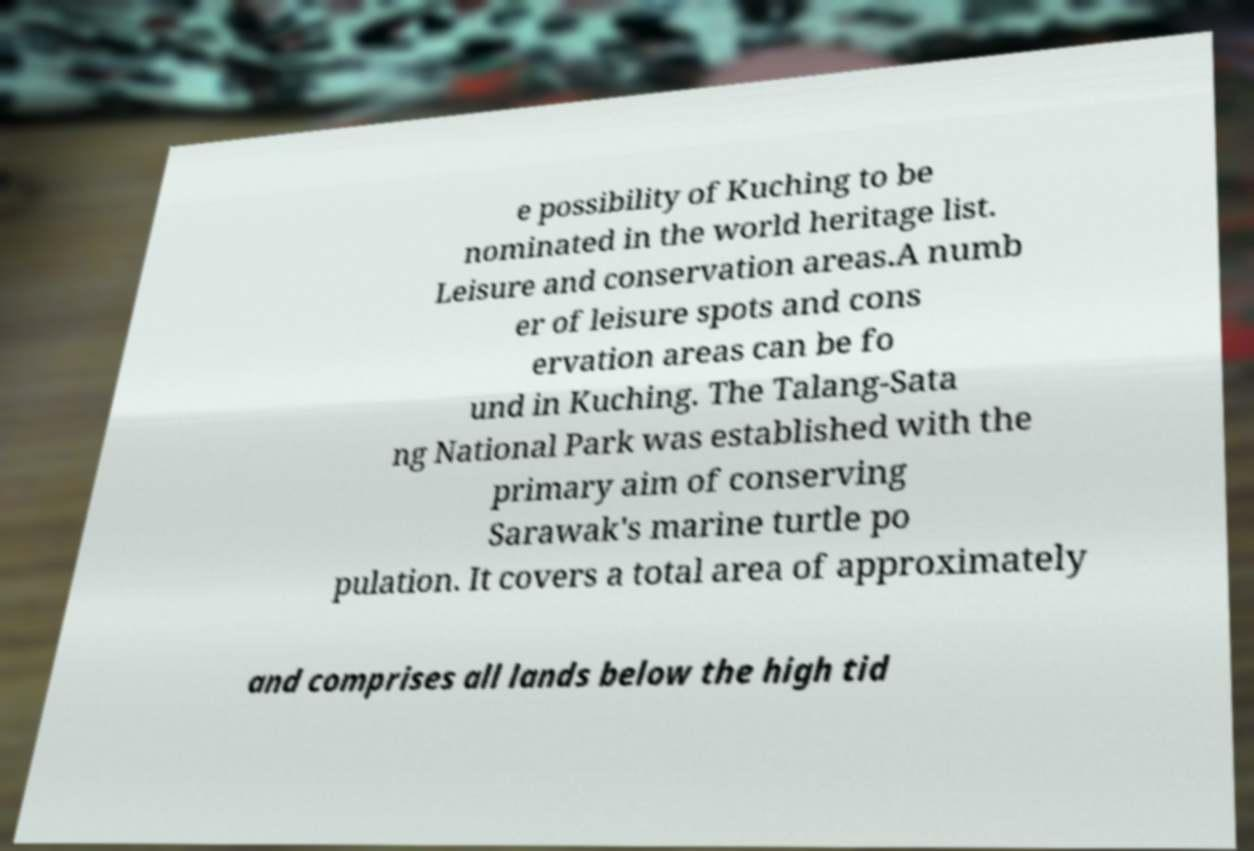For documentation purposes, I need the text within this image transcribed. Could you provide that? e possibility of Kuching to be nominated in the world heritage list. Leisure and conservation areas.A numb er of leisure spots and cons ervation areas can be fo und in Kuching. The Talang-Sata ng National Park was established with the primary aim of conserving Sarawak's marine turtle po pulation. It covers a total area of approximately and comprises all lands below the high tid 